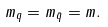<formula> <loc_0><loc_0><loc_500><loc_500>m _ { q } = m _ { \bar { q } } = m .</formula> 